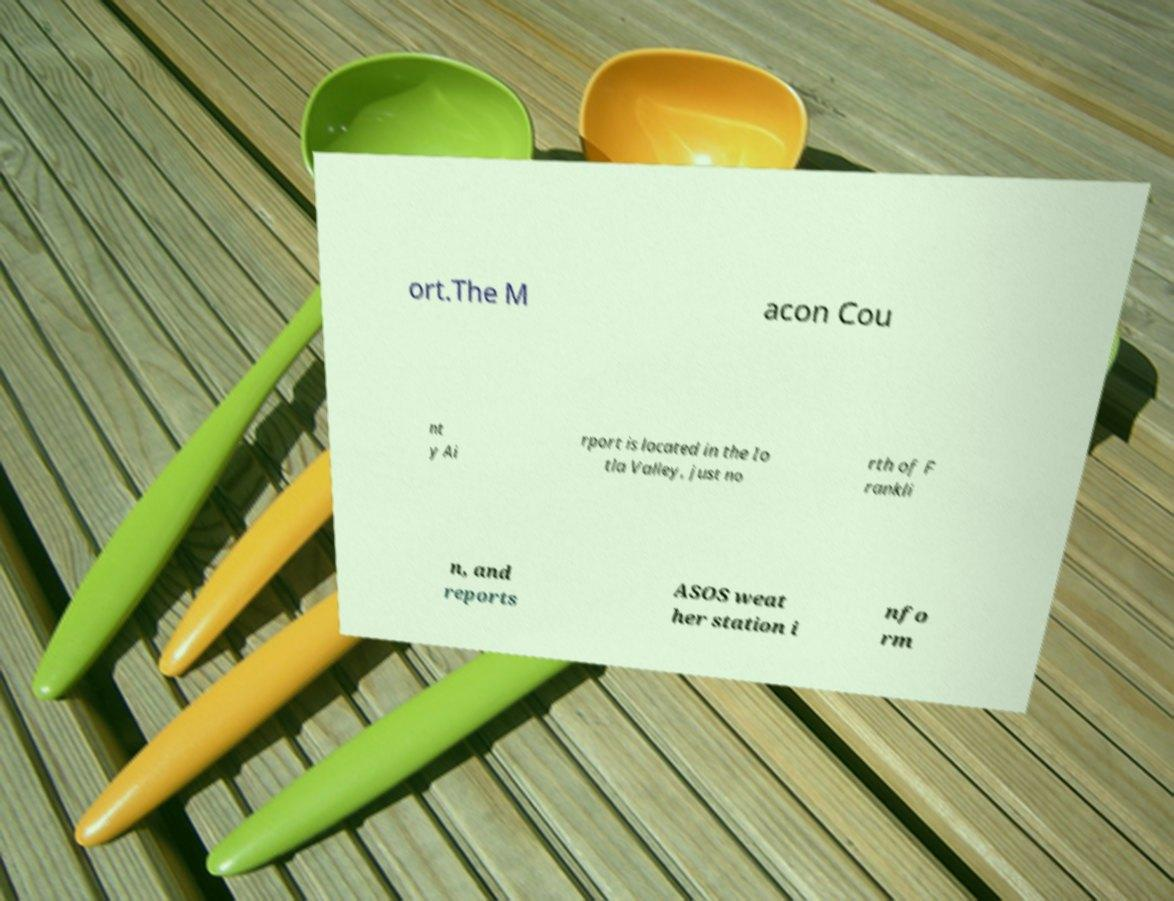Could you extract and type out the text from this image? ort.The M acon Cou nt y Ai rport is located in the Io tla Valley, just no rth of F rankli n, and reports ASOS weat her station i nfo rm 